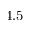Convert formula to latex. <formula><loc_0><loc_0><loc_500><loc_500>4 . 5</formula> 